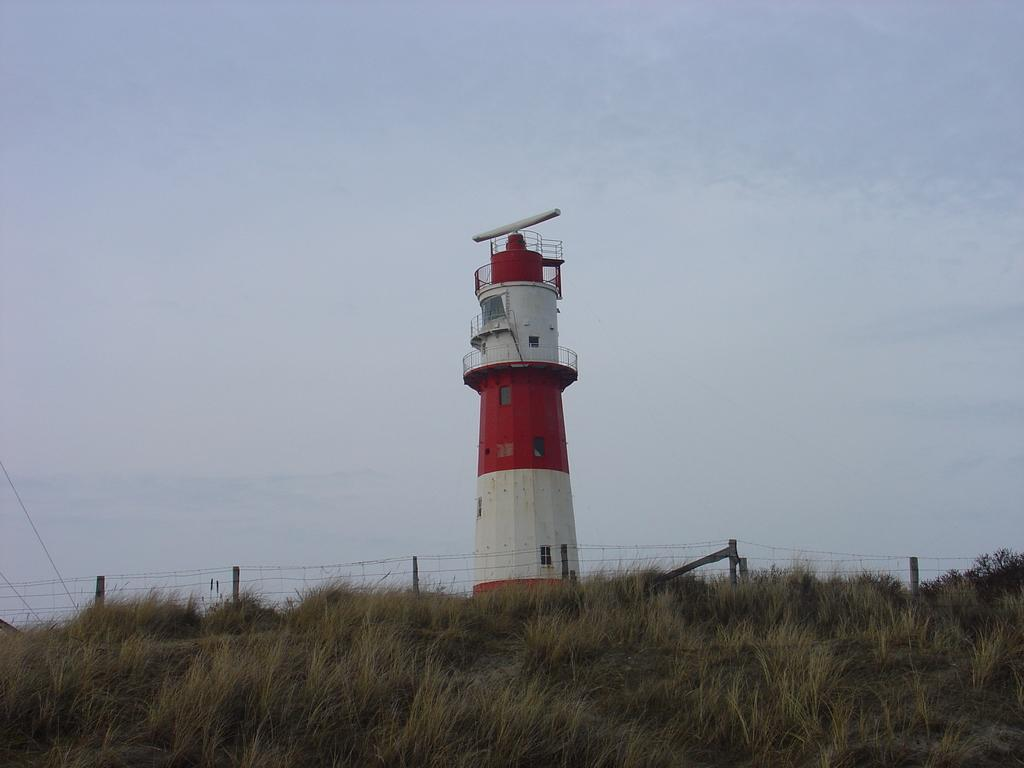What is the main structure in the image? There is a lighthouse in the image. What can be seen in the foreground of the image? There is a fence and grass in the foreground of the image. What is visible at the top of the image? The sky is visible at the top of the image. What type of crack is visible on the lighthouse in the image? There is no crack visible on the lighthouse in the image. What are the teeth of the lighthouse used for in the image? The lighthouse does not have teeth, as it is an inanimate object. 